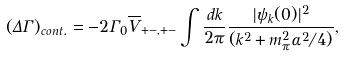Convert formula to latex. <formula><loc_0><loc_0><loc_500><loc_500>\left ( \Delta \Gamma \right ) _ { c o n t . } = - 2 \Gamma _ { 0 } \overline { V } _ { + - , + - } \int \frac { d k } { 2 \pi } \frac { | \psi _ { k } ( 0 ) | ^ { 2 } } { ( k ^ { 2 } + m _ { \pi } ^ { 2 } \alpha ^ { 2 } / 4 ) } ,</formula> 